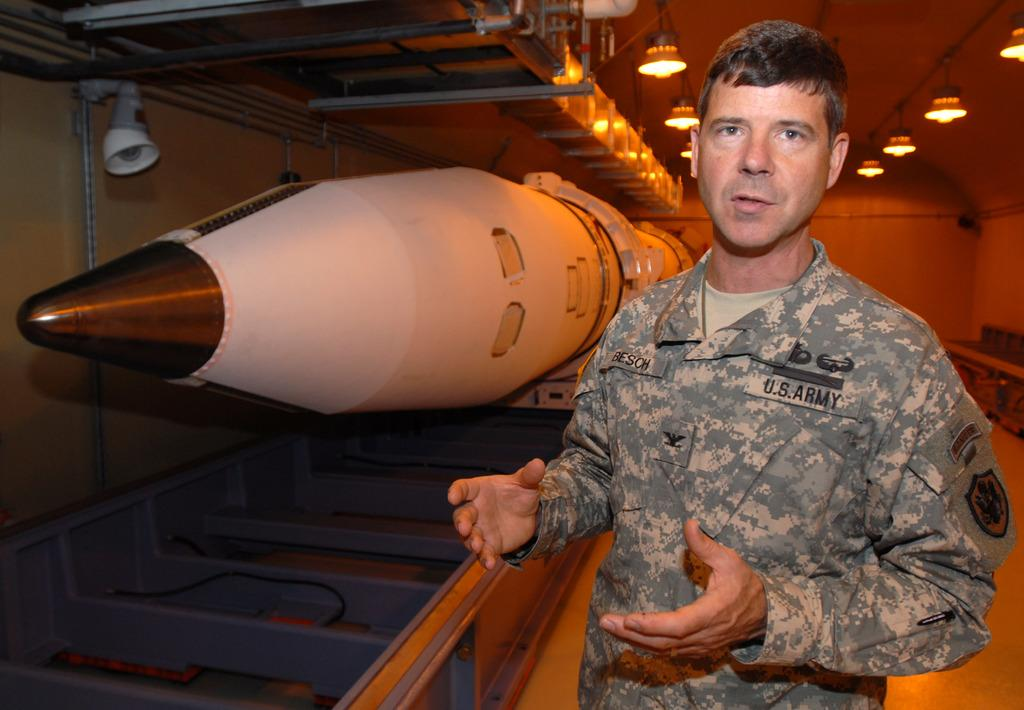What is the main subject in the image? There is a person standing in the image. What other object can be seen in the image? There is a rocket in the image. What is hanging from the roof in the image? The roof has lights hanging from it. What can be seen in the background of the image? There is a wall visible in the background of the image. How many crows are sitting on the rocket in the image? There are no crows present in the image; it only features a person and a rocket. What type of wool is used to make the person's clothing in the image? There is no information about the person's clothing or the use of wool in the image. 